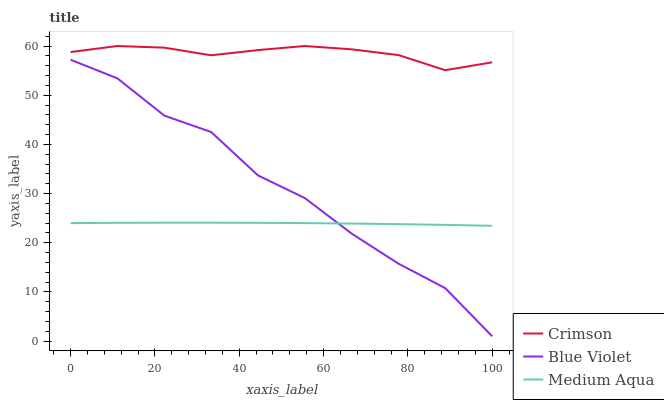Does Medium Aqua have the minimum area under the curve?
Answer yes or no. Yes. Does Crimson have the maximum area under the curve?
Answer yes or no. Yes. Does Blue Violet have the minimum area under the curve?
Answer yes or no. No. Does Blue Violet have the maximum area under the curve?
Answer yes or no. No. Is Medium Aqua the smoothest?
Answer yes or no. Yes. Is Blue Violet the roughest?
Answer yes or no. Yes. Is Blue Violet the smoothest?
Answer yes or no. No. Is Medium Aqua the roughest?
Answer yes or no. No. Does Blue Violet have the lowest value?
Answer yes or no. Yes. Does Medium Aqua have the lowest value?
Answer yes or no. No. Does Crimson have the highest value?
Answer yes or no. Yes. Does Blue Violet have the highest value?
Answer yes or no. No. Is Blue Violet less than Crimson?
Answer yes or no. Yes. Is Crimson greater than Medium Aqua?
Answer yes or no. Yes. Does Medium Aqua intersect Blue Violet?
Answer yes or no. Yes. Is Medium Aqua less than Blue Violet?
Answer yes or no. No. Is Medium Aqua greater than Blue Violet?
Answer yes or no. No. Does Blue Violet intersect Crimson?
Answer yes or no. No. 